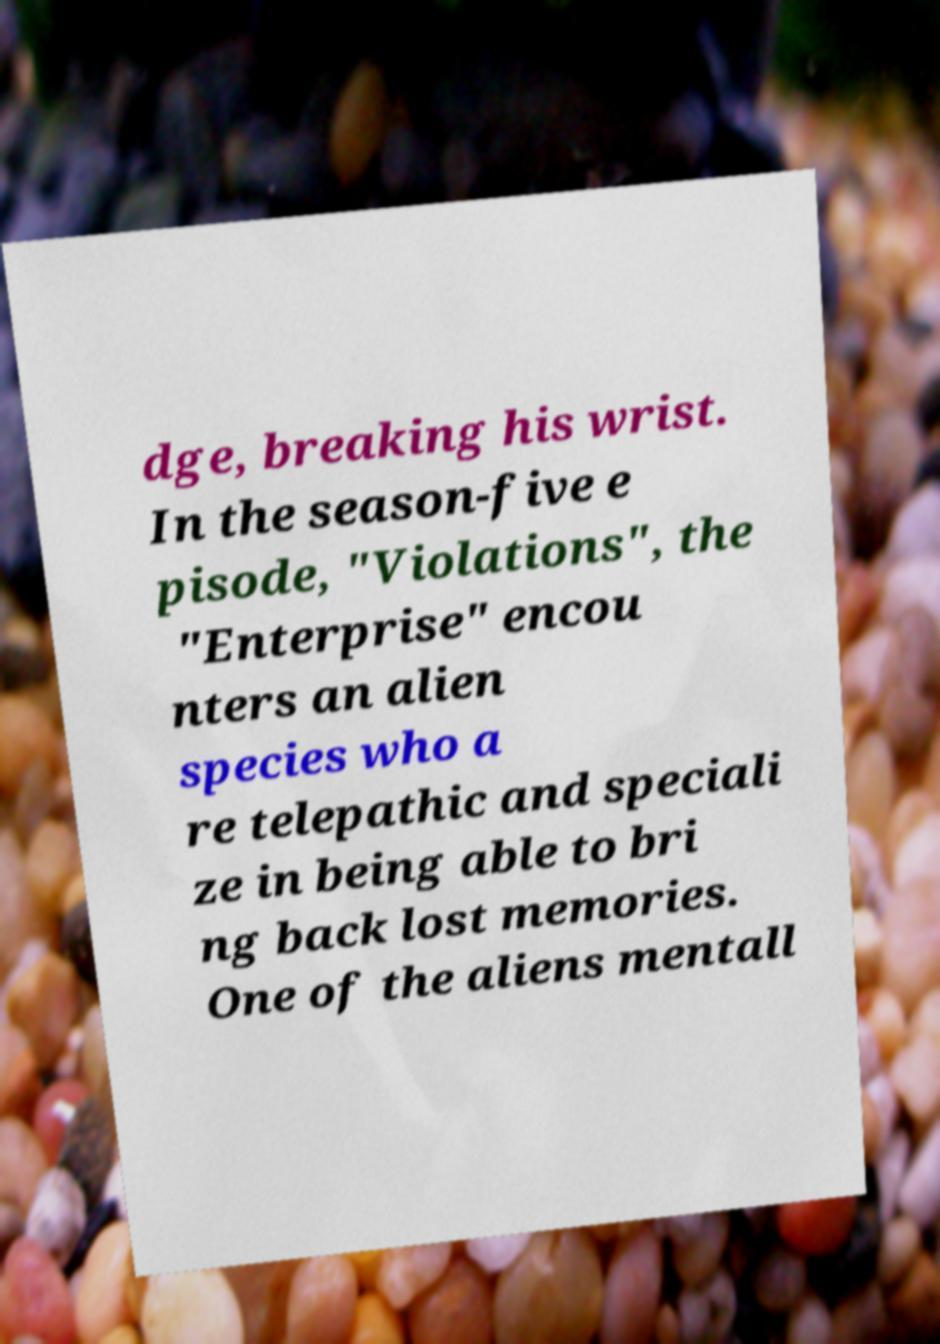Please read and relay the text visible in this image. What does it say? dge, breaking his wrist. In the season-five e pisode, "Violations", the "Enterprise" encou nters an alien species who a re telepathic and speciali ze in being able to bri ng back lost memories. One of the aliens mentall 